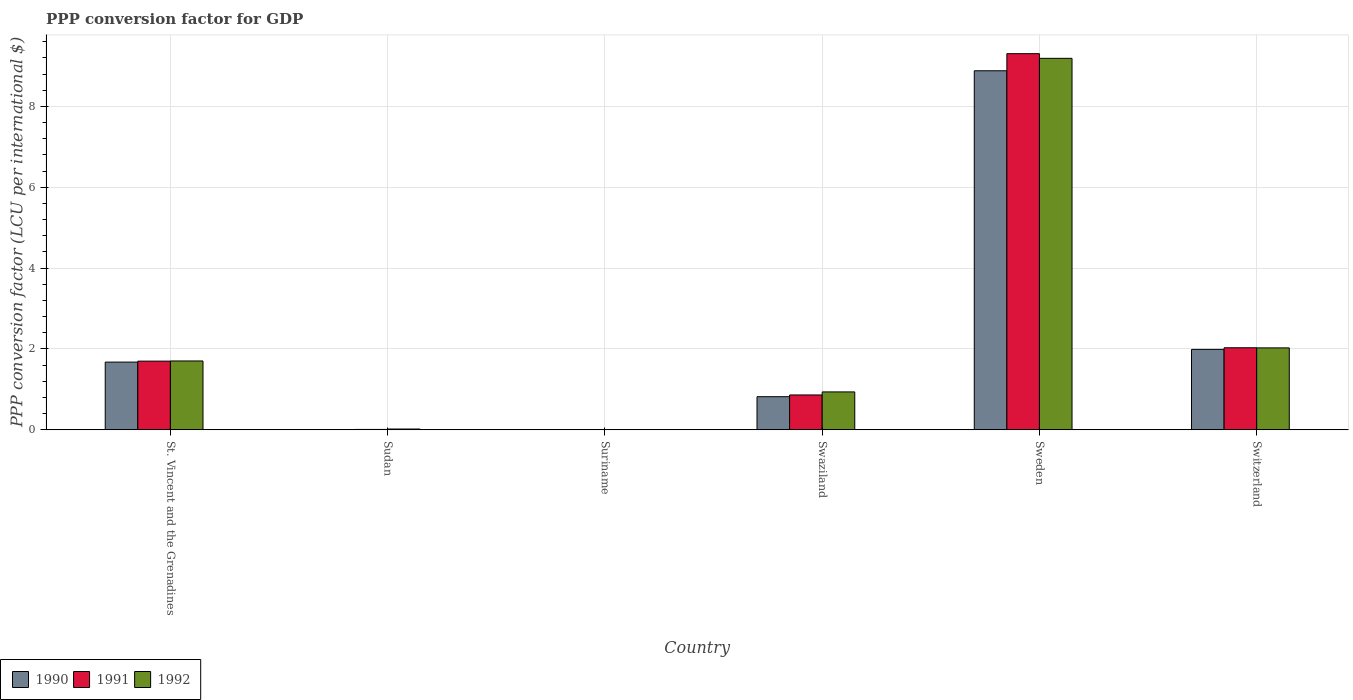How many different coloured bars are there?
Offer a terse response. 3. What is the label of the 5th group of bars from the left?
Your answer should be very brief. Sweden. What is the PPP conversion factor for GDP in 1990 in Swaziland?
Ensure brevity in your answer.  0.82. Across all countries, what is the maximum PPP conversion factor for GDP in 1990?
Make the answer very short. 8.88. Across all countries, what is the minimum PPP conversion factor for GDP in 1992?
Offer a terse response. 0. In which country was the PPP conversion factor for GDP in 1990 minimum?
Offer a terse response. Suriname. What is the total PPP conversion factor for GDP in 1990 in the graph?
Offer a very short reply. 13.37. What is the difference between the PPP conversion factor for GDP in 1990 in St. Vincent and the Grenadines and that in Swaziland?
Make the answer very short. 0.86. What is the difference between the PPP conversion factor for GDP in 1990 in St. Vincent and the Grenadines and the PPP conversion factor for GDP in 1991 in Swaziland?
Ensure brevity in your answer.  0.81. What is the average PPP conversion factor for GDP in 1991 per country?
Make the answer very short. 2.32. What is the difference between the PPP conversion factor for GDP of/in 1991 and PPP conversion factor for GDP of/in 1990 in Swaziland?
Provide a short and direct response. 0.04. What is the ratio of the PPP conversion factor for GDP in 1992 in St. Vincent and the Grenadines to that in Switzerland?
Your response must be concise. 0.84. Is the difference between the PPP conversion factor for GDP in 1991 in Sudan and Sweden greater than the difference between the PPP conversion factor for GDP in 1990 in Sudan and Sweden?
Ensure brevity in your answer.  No. What is the difference between the highest and the second highest PPP conversion factor for GDP in 1992?
Your answer should be compact. 7.16. What is the difference between the highest and the lowest PPP conversion factor for GDP in 1992?
Provide a short and direct response. 9.19. Is the sum of the PPP conversion factor for GDP in 1992 in Sudan and Swaziland greater than the maximum PPP conversion factor for GDP in 1991 across all countries?
Keep it short and to the point. No. What does the 1st bar from the right in Suriname represents?
Your answer should be compact. 1992. Is it the case that in every country, the sum of the PPP conversion factor for GDP in 1990 and PPP conversion factor for GDP in 1991 is greater than the PPP conversion factor for GDP in 1992?
Make the answer very short. No. How many bars are there?
Keep it short and to the point. 18. Are all the bars in the graph horizontal?
Offer a very short reply. No. What is the title of the graph?
Offer a terse response. PPP conversion factor for GDP. Does "2005" appear as one of the legend labels in the graph?
Your answer should be very brief. No. What is the label or title of the Y-axis?
Your answer should be very brief. PPP conversion factor (LCU per international $). What is the PPP conversion factor (LCU per international $) in 1990 in St. Vincent and the Grenadines?
Keep it short and to the point. 1.67. What is the PPP conversion factor (LCU per international $) in 1991 in St. Vincent and the Grenadines?
Your response must be concise. 1.7. What is the PPP conversion factor (LCU per international $) in 1992 in St. Vincent and the Grenadines?
Provide a succinct answer. 1.7. What is the PPP conversion factor (LCU per international $) of 1990 in Sudan?
Make the answer very short. 0.01. What is the PPP conversion factor (LCU per international $) in 1991 in Sudan?
Offer a terse response. 0.01. What is the PPP conversion factor (LCU per international $) in 1992 in Sudan?
Make the answer very short. 0.02. What is the PPP conversion factor (LCU per international $) of 1990 in Suriname?
Your answer should be very brief. 0. What is the PPP conversion factor (LCU per international $) in 1991 in Suriname?
Offer a terse response. 0. What is the PPP conversion factor (LCU per international $) of 1992 in Suriname?
Keep it short and to the point. 0. What is the PPP conversion factor (LCU per international $) in 1990 in Swaziland?
Provide a succinct answer. 0.82. What is the PPP conversion factor (LCU per international $) of 1991 in Swaziland?
Offer a very short reply. 0.86. What is the PPP conversion factor (LCU per international $) in 1992 in Swaziland?
Your response must be concise. 0.94. What is the PPP conversion factor (LCU per international $) in 1990 in Sweden?
Your answer should be very brief. 8.88. What is the PPP conversion factor (LCU per international $) in 1991 in Sweden?
Keep it short and to the point. 9.3. What is the PPP conversion factor (LCU per international $) in 1992 in Sweden?
Offer a very short reply. 9.19. What is the PPP conversion factor (LCU per international $) of 1990 in Switzerland?
Offer a very short reply. 1.99. What is the PPP conversion factor (LCU per international $) of 1991 in Switzerland?
Make the answer very short. 2.03. What is the PPP conversion factor (LCU per international $) in 1992 in Switzerland?
Provide a succinct answer. 2.03. Across all countries, what is the maximum PPP conversion factor (LCU per international $) in 1990?
Give a very brief answer. 8.88. Across all countries, what is the maximum PPP conversion factor (LCU per international $) of 1991?
Offer a terse response. 9.3. Across all countries, what is the maximum PPP conversion factor (LCU per international $) in 1992?
Make the answer very short. 9.19. Across all countries, what is the minimum PPP conversion factor (LCU per international $) of 1990?
Provide a short and direct response. 0. Across all countries, what is the minimum PPP conversion factor (LCU per international $) in 1991?
Provide a succinct answer. 0. Across all countries, what is the minimum PPP conversion factor (LCU per international $) in 1992?
Give a very brief answer. 0. What is the total PPP conversion factor (LCU per international $) of 1990 in the graph?
Provide a short and direct response. 13.37. What is the total PPP conversion factor (LCU per international $) of 1991 in the graph?
Your answer should be compact. 13.91. What is the total PPP conversion factor (LCU per international $) in 1992 in the graph?
Ensure brevity in your answer.  13.88. What is the difference between the PPP conversion factor (LCU per international $) of 1990 in St. Vincent and the Grenadines and that in Sudan?
Give a very brief answer. 1.67. What is the difference between the PPP conversion factor (LCU per international $) in 1991 in St. Vincent and the Grenadines and that in Sudan?
Provide a succinct answer. 1.69. What is the difference between the PPP conversion factor (LCU per international $) of 1992 in St. Vincent and the Grenadines and that in Sudan?
Offer a very short reply. 1.68. What is the difference between the PPP conversion factor (LCU per international $) in 1990 in St. Vincent and the Grenadines and that in Suriname?
Keep it short and to the point. 1.67. What is the difference between the PPP conversion factor (LCU per international $) of 1991 in St. Vincent and the Grenadines and that in Suriname?
Your response must be concise. 1.7. What is the difference between the PPP conversion factor (LCU per international $) in 1992 in St. Vincent and the Grenadines and that in Suriname?
Your response must be concise. 1.7. What is the difference between the PPP conversion factor (LCU per international $) of 1990 in St. Vincent and the Grenadines and that in Swaziland?
Keep it short and to the point. 0.86. What is the difference between the PPP conversion factor (LCU per international $) of 1991 in St. Vincent and the Grenadines and that in Swaziland?
Your answer should be very brief. 0.84. What is the difference between the PPP conversion factor (LCU per international $) of 1992 in St. Vincent and the Grenadines and that in Swaziland?
Provide a short and direct response. 0.77. What is the difference between the PPP conversion factor (LCU per international $) in 1990 in St. Vincent and the Grenadines and that in Sweden?
Your answer should be compact. -7.21. What is the difference between the PPP conversion factor (LCU per international $) in 1991 in St. Vincent and the Grenadines and that in Sweden?
Keep it short and to the point. -7.61. What is the difference between the PPP conversion factor (LCU per international $) of 1992 in St. Vincent and the Grenadines and that in Sweden?
Make the answer very short. -7.49. What is the difference between the PPP conversion factor (LCU per international $) of 1990 in St. Vincent and the Grenadines and that in Switzerland?
Offer a very short reply. -0.31. What is the difference between the PPP conversion factor (LCU per international $) of 1991 in St. Vincent and the Grenadines and that in Switzerland?
Provide a short and direct response. -0.33. What is the difference between the PPP conversion factor (LCU per international $) of 1992 in St. Vincent and the Grenadines and that in Switzerland?
Offer a terse response. -0.32. What is the difference between the PPP conversion factor (LCU per international $) in 1990 in Sudan and that in Suriname?
Provide a short and direct response. 0. What is the difference between the PPP conversion factor (LCU per international $) of 1991 in Sudan and that in Suriname?
Make the answer very short. 0.01. What is the difference between the PPP conversion factor (LCU per international $) of 1992 in Sudan and that in Suriname?
Ensure brevity in your answer.  0.02. What is the difference between the PPP conversion factor (LCU per international $) in 1990 in Sudan and that in Swaziland?
Provide a succinct answer. -0.81. What is the difference between the PPP conversion factor (LCU per international $) of 1991 in Sudan and that in Swaziland?
Your answer should be compact. -0.85. What is the difference between the PPP conversion factor (LCU per international $) in 1992 in Sudan and that in Swaziland?
Make the answer very short. -0.92. What is the difference between the PPP conversion factor (LCU per international $) of 1990 in Sudan and that in Sweden?
Offer a very short reply. -8.88. What is the difference between the PPP conversion factor (LCU per international $) of 1991 in Sudan and that in Sweden?
Provide a short and direct response. -9.3. What is the difference between the PPP conversion factor (LCU per international $) of 1992 in Sudan and that in Sweden?
Offer a terse response. -9.17. What is the difference between the PPP conversion factor (LCU per international $) of 1990 in Sudan and that in Switzerland?
Your response must be concise. -1.98. What is the difference between the PPP conversion factor (LCU per international $) of 1991 in Sudan and that in Switzerland?
Offer a terse response. -2.02. What is the difference between the PPP conversion factor (LCU per international $) in 1992 in Sudan and that in Switzerland?
Ensure brevity in your answer.  -2.01. What is the difference between the PPP conversion factor (LCU per international $) of 1990 in Suriname and that in Swaziland?
Offer a terse response. -0.82. What is the difference between the PPP conversion factor (LCU per international $) of 1991 in Suriname and that in Swaziland?
Your response must be concise. -0.86. What is the difference between the PPP conversion factor (LCU per international $) in 1992 in Suriname and that in Swaziland?
Provide a short and direct response. -0.94. What is the difference between the PPP conversion factor (LCU per international $) in 1990 in Suriname and that in Sweden?
Your answer should be compact. -8.88. What is the difference between the PPP conversion factor (LCU per international $) in 1991 in Suriname and that in Sweden?
Ensure brevity in your answer.  -9.3. What is the difference between the PPP conversion factor (LCU per international $) in 1992 in Suriname and that in Sweden?
Ensure brevity in your answer.  -9.19. What is the difference between the PPP conversion factor (LCU per international $) of 1990 in Suriname and that in Switzerland?
Provide a succinct answer. -1.99. What is the difference between the PPP conversion factor (LCU per international $) in 1991 in Suriname and that in Switzerland?
Make the answer very short. -2.03. What is the difference between the PPP conversion factor (LCU per international $) in 1992 in Suriname and that in Switzerland?
Your response must be concise. -2.02. What is the difference between the PPP conversion factor (LCU per international $) of 1990 in Swaziland and that in Sweden?
Provide a short and direct response. -8.06. What is the difference between the PPP conversion factor (LCU per international $) in 1991 in Swaziland and that in Sweden?
Provide a succinct answer. -8.44. What is the difference between the PPP conversion factor (LCU per international $) of 1992 in Swaziland and that in Sweden?
Your answer should be very brief. -8.25. What is the difference between the PPP conversion factor (LCU per international $) of 1990 in Swaziland and that in Switzerland?
Offer a terse response. -1.17. What is the difference between the PPP conversion factor (LCU per international $) in 1991 in Swaziland and that in Switzerland?
Your answer should be very brief. -1.17. What is the difference between the PPP conversion factor (LCU per international $) of 1992 in Swaziland and that in Switzerland?
Your answer should be very brief. -1.09. What is the difference between the PPP conversion factor (LCU per international $) in 1990 in Sweden and that in Switzerland?
Your response must be concise. 6.89. What is the difference between the PPP conversion factor (LCU per international $) of 1991 in Sweden and that in Switzerland?
Offer a very short reply. 7.28. What is the difference between the PPP conversion factor (LCU per international $) of 1992 in Sweden and that in Switzerland?
Provide a short and direct response. 7.16. What is the difference between the PPP conversion factor (LCU per international $) of 1990 in St. Vincent and the Grenadines and the PPP conversion factor (LCU per international $) of 1991 in Sudan?
Provide a succinct answer. 1.67. What is the difference between the PPP conversion factor (LCU per international $) in 1990 in St. Vincent and the Grenadines and the PPP conversion factor (LCU per international $) in 1992 in Sudan?
Provide a succinct answer. 1.66. What is the difference between the PPP conversion factor (LCU per international $) of 1991 in St. Vincent and the Grenadines and the PPP conversion factor (LCU per international $) of 1992 in Sudan?
Ensure brevity in your answer.  1.68. What is the difference between the PPP conversion factor (LCU per international $) in 1990 in St. Vincent and the Grenadines and the PPP conversion factor (LCU per international $) in 1991 in Suriname?
Provide a succinct answer. 1.67. What is the difference between the PPP conversion factor (LCU per international $) of 1990 in St. Vincent and the Grenadines and the PPP conversion factor (LCU per international $) of 1992 in Suriname?
Provide a succinct answer. 1.67. What is the difference between the PPP conversion factor (LCU per international $) in 1991 in St. Vincent and the Grenadines and the PPP conversion factor (LCU per international $) in 1992 in Suriname?
Make the answer very short. 1.7. What is the difference between the PPP conversion factor (LCU per international $) of 1990 in St. Vincent and the Grenadines and the PPP conversion factor (LCU per international $) of 1991 in Swaziland?
Your answer should be compact. 0.81. What is the difference between the PPP conversion factor (LCU per international $) in 1990 in St. Vincent and the Grenadines and the PPP conversion factor (LCU per international $) in 1992 in Swaziland?
Give a very brief answer. 0.74. What is the difference between the PPP conversion factor (LCU per international $) in 1991 in St. Vincent and the Grenadines and the PPP conversion factor (LCU per international $) in 1992 in Swaziland?
Your response must be concise. 0.76. What is the difference between the PPP conversion factor (LCU per international $) in 1990 in St. Vincent and the Grenadines and the PPP conversion factor (LCU per international $) in 1991 in Sweden?
Make the answer very short. -7.63. What is the difference between the PPP conversion factor (LCU per international $) of 1990 in St. Vincent and the Grenadines and the PPP conversion factor (LCU per international $) of 1992 in Sweden?
Provide a succinct answer. -7.52. What is the difference between the PPP conversion factor (LCU per international $) of 1991 in St. Vincent and the Grenadines and the PPP conversion factor (LCU per international $) of 1992 in Sweden?
Give a very brief answer. -7.49. What is the difference between the PPP conversion factor (LCU per international $) of 1990 in St. Vincent and the Grenadines and the PPP conversion factor (LCU per international $) of 1991 in Switzerland?
Your answer should be very brief. -0.35. What is the difference between the PPP conversion factor (LCU per international $) of 1990 in St. Vincent and the Grenadines and the PPP conversion factor (LCU per international $) of 1992 in Switzerland?
Provide a short and direct response. -0.35. What is the difference between the PPP conversion factor (LCU per international $) in 1991 in St. Vincent and the Grenadines and the PPP conversion factor (LCU per international $) in 1992 in Switzerland?
Ensure brevity in your answer.  -0.33. What is the difference between the PPP conversion factor (LCU per international $) in 1990 in Sudan and the PPP conversion factor (LCU per international $) in 1991 in Suriname?
Your response must be concise. 0. What is the difference between the PPP conversion factor (LCU per international $) in 1990 in Sudan and the PPP conversion factor (LCU per international $) in 1992 in Suriname?
Provide a short and direct response. 0. What is the difference between the PPP conversion factor (LCU per international $) in 1991 in Sudan and the PPP conversion factor (LCU per international $) in 1992 in Suriname?
Provide a short and direct response. 0.01. What is the difference between the PPP conversion factor (LCU per international $) in 1990 in Sudan and the PPP conversion factor (LCU per international $) in 1991 in Swaziland?
Give a very brief answer. -0.86. What is the difference between the PPP conversion factor (LCU per international $) of 1990 in Sudan and the PPP conversion factor (LCU per international $) of 1992 in Swaziland?
Keep it short and to the point. -0.93. What is the difference between the PPP conversion factor (LCU per international $) in 1991 in Sudan and the PPP conversion factor (LCU per international $) in 1992 in Swaziland?
Your response must be concise. -0.93. What is the difference between the PPP conversion factor (LCU per international $) in 1990 in Sudan and the PPP conversion factor (LCU per international $) in 1991 in Sweden?
Keep it short and to the point. -9.3. What is the difference between the PPP conversion factor (LCU per international $) of 1990 in Sudan and the PPP conversion factor (LCU per international $) of 1992 in Sweden?
Keep it short and to the point. -9.18. What is the difference between the PPP conversion factor (LCU per international $) of 1991 in Sudan and the PPP conversion factor (LCU per international $) of 1992 in Sweden?
Offer a very short reply. -9.18. What is the difference between the PPP conversion factor (LCU per international $) in 1990 in Sudan and the PPP conversion factor (LCU per international $) in 1991 in Switzerland?
Provide a succinct answer. -2.02. What is the difference between the PPP conversion factor (LCU per international $) of 1990 in Sudan and the PPP conversion factor (LCU per international $) of 1992 in Switzerland?
Keep it short and to the point. -2.02. What is the difference between the PPP conversion factor (LCU per international $) of 1991 in Sudan and the PPP conversion factor (LCU per international $) of 1992 in Switzerland?
Offer a terse response. -2.02. What is the difference between the PPP conversion factor (LCU per international $) of 1990 in Suriname and the PPP conversion factor (LCU per international $) of 1991 in Swaziland?
Your answer should be very brief. -0.86. What is the difference between the PPP conversion factor (LCU per international $) of 1990 in Suriname and the PPP conversion factor (LCU per international $) of 1992 in Swaziland?
Your answer should be compact. -0.94. What is the difference between the PPP conversion factor (LCU per international $) in 1991 in Suriname and the PPP conversion factor (LCU per international $) in 1992 in Swaziland?
Offer a terse response. -0.94. What is the difference between the PPP conversion factor (LCU per international $) in 1990 in Suriname and the PPP conversion factor (LCU per international $) in 1991 in Sweden?
Offer a terse response. -9.3. What is the difference between the PPP conversion factor (LCU per international $) of 1990 in Suriname and the PPP conversion factor (LCU per international $) of 1992 in Sweden?
Provide a short and direct response. -9.19. What is the difference between the PPP conversion factor (LCU per international $) in 1991 in Suriname and the PPP conversion factor (LCU per international $) in 1992 in Sweden?
Your response must be concise. -9.19. What is the difference between the PPP conversion factor (LCU per international $) in 1990 in Suriname and the PPP conversion factor (LCU per international $) in 1991 in Switzerland?
Your answer should be compact. -2.03. What is the difference between the PPP conversion factor (LCU per international $) in 1990 in Suriname and the PPP conversion factor (LCU per international $) in 1992 in Switzerland?
Your response must be concise. -2.03. What is the difference between the PPP conversion factor (LCU per international $) of 1991 in Suriname and the PPP conversion factor (LCU per international $) of 1992 in Switzerland?
Your answer should be very brief. -2.02. What is the difference between the PPP conversion factor (LCU per international $) of 1990 in Swaziland and the PPP conversion factor (LCU per international $) of 1991 in Sweden?
Provide a succinct answer. -8.49. What is the difference between the PPP conversion factor (LCU per international $) in 1990 in Swaziland and the PPP conversion factor (LCU per international $) in 1992 in Sweden?
Your answer should be compact. -8.37. What is the difference between the PPP conversion factor (LCU per international $) in 1991 in Swaziland and the PPP conversion factor (LCU per international $) in 1992 in Sweden?
Your answer should be very brief. -8.33. What is the difference between the PPP conversion factor (LCU per international $) in 1990 in Swaziland and the PPP conversion factor (LCU per international $) in 1991 in Switzerland?
Your answer should be very brief. -1.21. What is the difference between the PPP conversion factor (LCU per international $) in 1990 in Swaziland and the PPP conversion factor (LCU per international $) in 1992 in Switzerland?
Make the answer very short. -1.21. What is the difference between the PPP conversion factor (LCU per international $) of 1991 in Swaziland and the PPP conversion factor (LCU per international $) of 1992 in Switzerland?
Your response must be concise. -1.16. What is the difference between the PPP conversion factor (LCU per international $) of 1990 in Sweden and the PPP conversion factor (LCU per international $) of 1991 in Switzerland?
Ensure brevity in your answer.  6.85. What is the difference between the PPP conversion factor (LCU per international $) of 1990 in Sweden and the PPP conversion factor (LCU per international $) of 1992 in Switzerland?
Make the answer very short. 6.86. What is the difference between the PPP conversion factor (LCU per international $) of 1991 in Sweden and the PPP conversion factor (LCU per international $) of 1992 in Switzerland?
Your answer should be very brief. 7.28. What is the average PPP conversion factor (LCU per international $) of 1990 per country?
Offer a terse response. 2.23. What is the average PPP conversion factor (LCU per international $) in 1991 per country?
Ensure brevity in your answer.  2.32. What is the average PPP conversion factor (LCU per international $) of 1992 per country?
Make the answer very short. 2.31. What is the difference between the PPP conversion factor (LCU per international $) of 1990 and PPP conversion factor (LCU per international $) of 1991 in St. Vincent and the Grenadines?
Ensure brevity in your answer.  -0.02. What is the difference between the PPP conversion factor (LCU per international $) in 1990 and PPP conversion factor (LCU per international $) in 1992 in St. Vincent and the Grenadines?
Give a very brief answer. -0.03. What is the difference between the PPP conversion factor (LCU per international $) of 1991 and PPP conversion factor (LCU per international $) of 1992 in St. Vincent and the Grenadines?
Keep it short and to the point. -0. What is the difference between the PPP conversion factor (LCU per international $) of 1990 and PPP conversion factor (LCU per international $) of 1991 in Sudan?
Your answer should be very brief. -0. What is the difference between the PPP conversion factor (LCU per international $) in 1990 and PPP conversion factor (LCU per international $) in 1992 in Sudan?
Offer a very short reply. -0.01. What is the difference between the PPP conversion factor (LCU per international $) in 1991 and PPP conversion factor (LCU per international $) in 1992 in Sudan?
Your answer should be very brief. -0.01. What is the difference between the PPP conversion factor (LCU per international $) of 1990 and PPP conversion factor (LCU per international $) of 1991 in Suriname?
Provide a succinct answer. -0. What is the difference between the PPP conversion factor (LCU per international $) of 1990 and PPP conversion factor (LCU per international $) of 1992 in Suriname?
Keep it short and to the point. -0. What is the difference between the PPP conversion factor (LCU per international $) in 1991 and PPP conversion factor (LCU per international $) in 1992 in Suriname?
Offer a terse response. -0. What is the difference between the PPP conversion factor (LCU per international $) of 1990 and PPP conversion factor (LCU per international $) of 1991 in Swaziland?
Ensure brevity in your answer.  -0.04. What is the difference between the PPP conversion factor (LCU per international $) in 1990 and PPP conversion factor (LCU per international $) in 1992 in Swaziland?
Your answer should be very brief. -0.12. What is the difference between the PPP conversion factor (LCU per international $) of 1991 and PPP conversion factor (LCU per international $) of 1992 in Swaziland?
Provide a short and direct response. -0.08. What is the difference between the PPP conversion factor (LCU per international $) in 1990 and PPP conversion factor (LCU per international $) in 1991 in Sweden?
Your answer should be very brief. -0.42. What is the difference between the PPP conversion factor (LCU per international $) of 1990 and PPP conversion factor (LCU per international $) of 1992 in Sweden?
Your answer should be very brief. -0.31. What is the difference between the PPP conversion factor (LCU per international $) of 1991 and PPP conversion factor (LCU per international $) of 1992 in Sweden?
Make the answer very short. 0.12. What is the difference between the PPP conversion factor (LCU per international $) in 1990 and PPP conversion factor (LCU per international $) in 1991 in Switzerland?
Offer a terse response. -0.04. What is the difference between the PPP conversion factor (LCU per international $) in 1990 and PPP conversion factor (LCU per international $) in 1992 in Switzerland?
Your answer should be compact. -0.04. What is the difference between the PPP conversion factor (LCU per international $) in 1991 and PPP conversion factor (LCU per international $) in 1992 in Switzerland?
Offer a very short reply. 0. What is the ratio of the PPP conversion factor (LCU per international $) in 1990 in St. Vincent and the Grenadines to that in Sudan?
Keep it short and to the point. 323.07. What is the ratio of the PPP conversion factor (LCU per international $) in 1991 in St. Vincent and the Grenadines to that in Sudan?
Make the answer very short. 179.4. What is the ratio of the PPP conversion factor (LCU per international $) of 1992 in St. Vincent and the Grenadines to that in Sudan?
Your answer should be very brief. 87.92. What is the ratio of the PPP conversion factor (LCU per international $) in 1990 in St. Vincent and the Grenadines to that in Suriname?
Your response must be concise. 1204.54. What is the ratio of the PPP conversion factor (LCU per international $) of 1991 in St. Vincent and the Grenadines to that in Suriname?
Give a very brief answer. 1124.12. What is the ratio of the PPP conversion factor (LCU per international $) in 1992 in St. Vincent and the Grenadines to that in Suriname?
Provide a short and direct response. 849.7. What is the ratio of the PPP conversion factor (LCU per international $) of 1990 in St. Vincent and the Grenadines to that in Swaziland?
Give a very brief answer. 2.04. What is the ratio of the PPP conversion factor (LCU per international $) of 1991 in St. Vincent and the Grenadines to that in Swaziland?
Ensure brevity in your answer.  1.97. What is the ratio of the PPP conversion factor (LCU per international $) of 1992 in St. Vincent and the Grenadines to that in Swaziland?
Your answer should be very brief. 1.82. What is the ratio of the PPP conversion factor (LCU per international $) in 1990 in St. Vincent and the Grenadines to that in Sweden?
Your response must be concise. 0.19. What is the ratio of the PPP conversion factor (LCU per international $) in 1991 in St. Vincent and the Grenadines to that in Sweden?
Make the answer very short. 0.18. What is the ratio of the PPP conversion factor (LCU per international $) in 1992 in St. Vincent and the Grenadines to that in Sweden?
Provide a short and direct response. 0.19. What is the ratio of the PPP conversion factor (LCU per international $) of 1990 in St. Vincent and the Grenadines to that in Switzerland?
Offer a very short reply. 0.84. What is the ratio of the PPP conversion factor (LCU per international $) in 1991 in St. Vincent and the Grenadines to that in Switzerland?
Offer a very short reply. 0.84. What is the ratio of the PPP conversion factor (LCU per international $) of 1992 in St. Vincent and the Grenadines to that in Switzerland?
Give a very brief answer. 0.84. What is the ratio of the PPP conversion factor (LCU per international $) of 1990 in Sudan to that in Suriname?
Provide a short and direct response. 3.73. What is the ratio of the PPP conversion factor (LCU per international $) of 1991 in Sudan to that in Suriname?
Offer a very short reply. 6.27. What is the ratio of the PPP conversion factor (LCU per international $) of 1992 in Sudan to that in Suriname?
Give a very brief answer. 9.66. What is the ratio of the PPP conversion factor (LCU per international $) of 1990 in Sudan to that in Swaziland?
Your answer should be very brief. 0.01. What is the ratio of the PPP conversion factor (LCU per international $) in 1991 in Sudan to that in Swaziland?
Keep it short and to the point. 0.01. What is the ratio of the PPP conversion factor (LCU per international $) in 1992 in Sudan to that in Swaziland?
Ensure brevity in your answer.  0.02. What is the ratio of the PPP conversion factor (LCU per international $) in 1990 in Sudan to that in Sweden?
Provide a succinct answer. 0. What is the ratio of the PPP conversion factor (LCU per international $) in 1992 in Sudan to that in Sweden?
Your answer should be compact. 0. What is the ratio of the PPP conversion factor (LCU per international $) of 1990 in Sudan to that in Switzerland?
Offer a terse response. 0. What is the ratio of the PPP conversion factor (LCU per international $) of 1991 in Sudan to that in Switzerland?
Make the answer very short. 0. What is the ratio of the PPP conversion factor (LCU per international $) in 1992 in Sudan to that in Switzerland?
Your response must be concise. 0.01. What is the ratio of the PPP conversion factor (LCU per international $) of 1990 in Suriname to that in Swaziland?
Provide a short and direct response. 0. What is the ratio of the PPP conversion factor (LCU per international $) of 1991 in Suriname to that in Swaziland?
Your answer should be very brief. 0. What is the ratio of the PPP conversion factor (LCU per international $) in 1992 in Suriname to that in Swaziland?
Give a very brief answer. 0. What is the ratio of the PPP conversion factor (LCU per international $) in 1990 in Suriname to that in Sweden?
Your response must be concise. 0. What is the ratio of the PPP conversion factor (LCU per international $) in 1991 in Suriname to that in Sweden?
Make the answer very short. 0. What is the ratio of the PPP conversion factor (LCU per international $) of 1990 in Suriname to that in Switzerland?
Give a very brief answer. 0. What is the ratio of the PPP conversion factor (LCU per international $) in 1991 in Suriname to that in Switzerland?
Your answer should be compact. 0. What is the ratio of the PPP conversion factor (LCU per international $) of 1992 in Suriname to that in Switzerland?
Provide a succinct answer. 0. What is the ratio of the PPP conversion factor (LCU per international $) in 1990 in Swaziland to that in Sweden?
Your response must be concise. 0.09. What is the ratio of the PPP conversion factor (LCU per international $) of 1991 in Swaziland to that in Sweden?
Keep it short and to the point. 0.09. What is the ratio of the PPP conversion factor (LCU per international $) of 1992 in Swaziland to that in Sweden?
Offer a terse response. 0.1. What is the ratio of the PPP conversion factor (LCU per international $) of 1990 in Swaziland to that in Switzerland?
Your response must be concise. 0.41. What is the ratio of the PPP conversion factor (LCU per international $) of 1991 in Swaziland to that in Switzerland?
Your answer should be compact. 0.42. What is the ratio of the PPP conversion factor (LCU per international $) of 1992 in Swaziland to that in Switzerland?
Give a very brief answer. 0.46. What is the ratio of the PPP conversion factor (LCU per international $) in 1990 in Sweden to that in Switzerland?
Your answer should be compact. 4.46. What is the ratio of the PPP conversion factor (LCU per international $) of 1991 in Sweden to that in Switzerland?
Offer a very short reply. 4.58. What is the ratio of the PPP conversion factor (LCU per international $) of 1992 in Sweden to that in Switzerland?
Make the answer very short. 4.53. What is the difference between the highest and the second highest PPP conversion factor (LCU per international $) in 1990?
Your answer should be compact. 6.89. What is the difference between the highest and the second highest PPP conversion factor (LCU per international $) of 1991?
Offer a very short reply. 7.28. What is the difference between the highest and the second highest PPP conversion factor (LCU per international $) in 1992?
Your answer should be compact. 7.16. What is the difference between the highest and the lowest PPP conversion factor (LCU per international $) in 1990?
Your answer should be compact. 8.88. What is the difference between the highest and the lowest PPP conversion factor (LCU per international $) of 1991?
Offer a very short reply. 9.3. What is the difference between the highest and the lowest PPP conversion factor (LCU per international $) in 1992?
Offer a terse response. 9.19. 